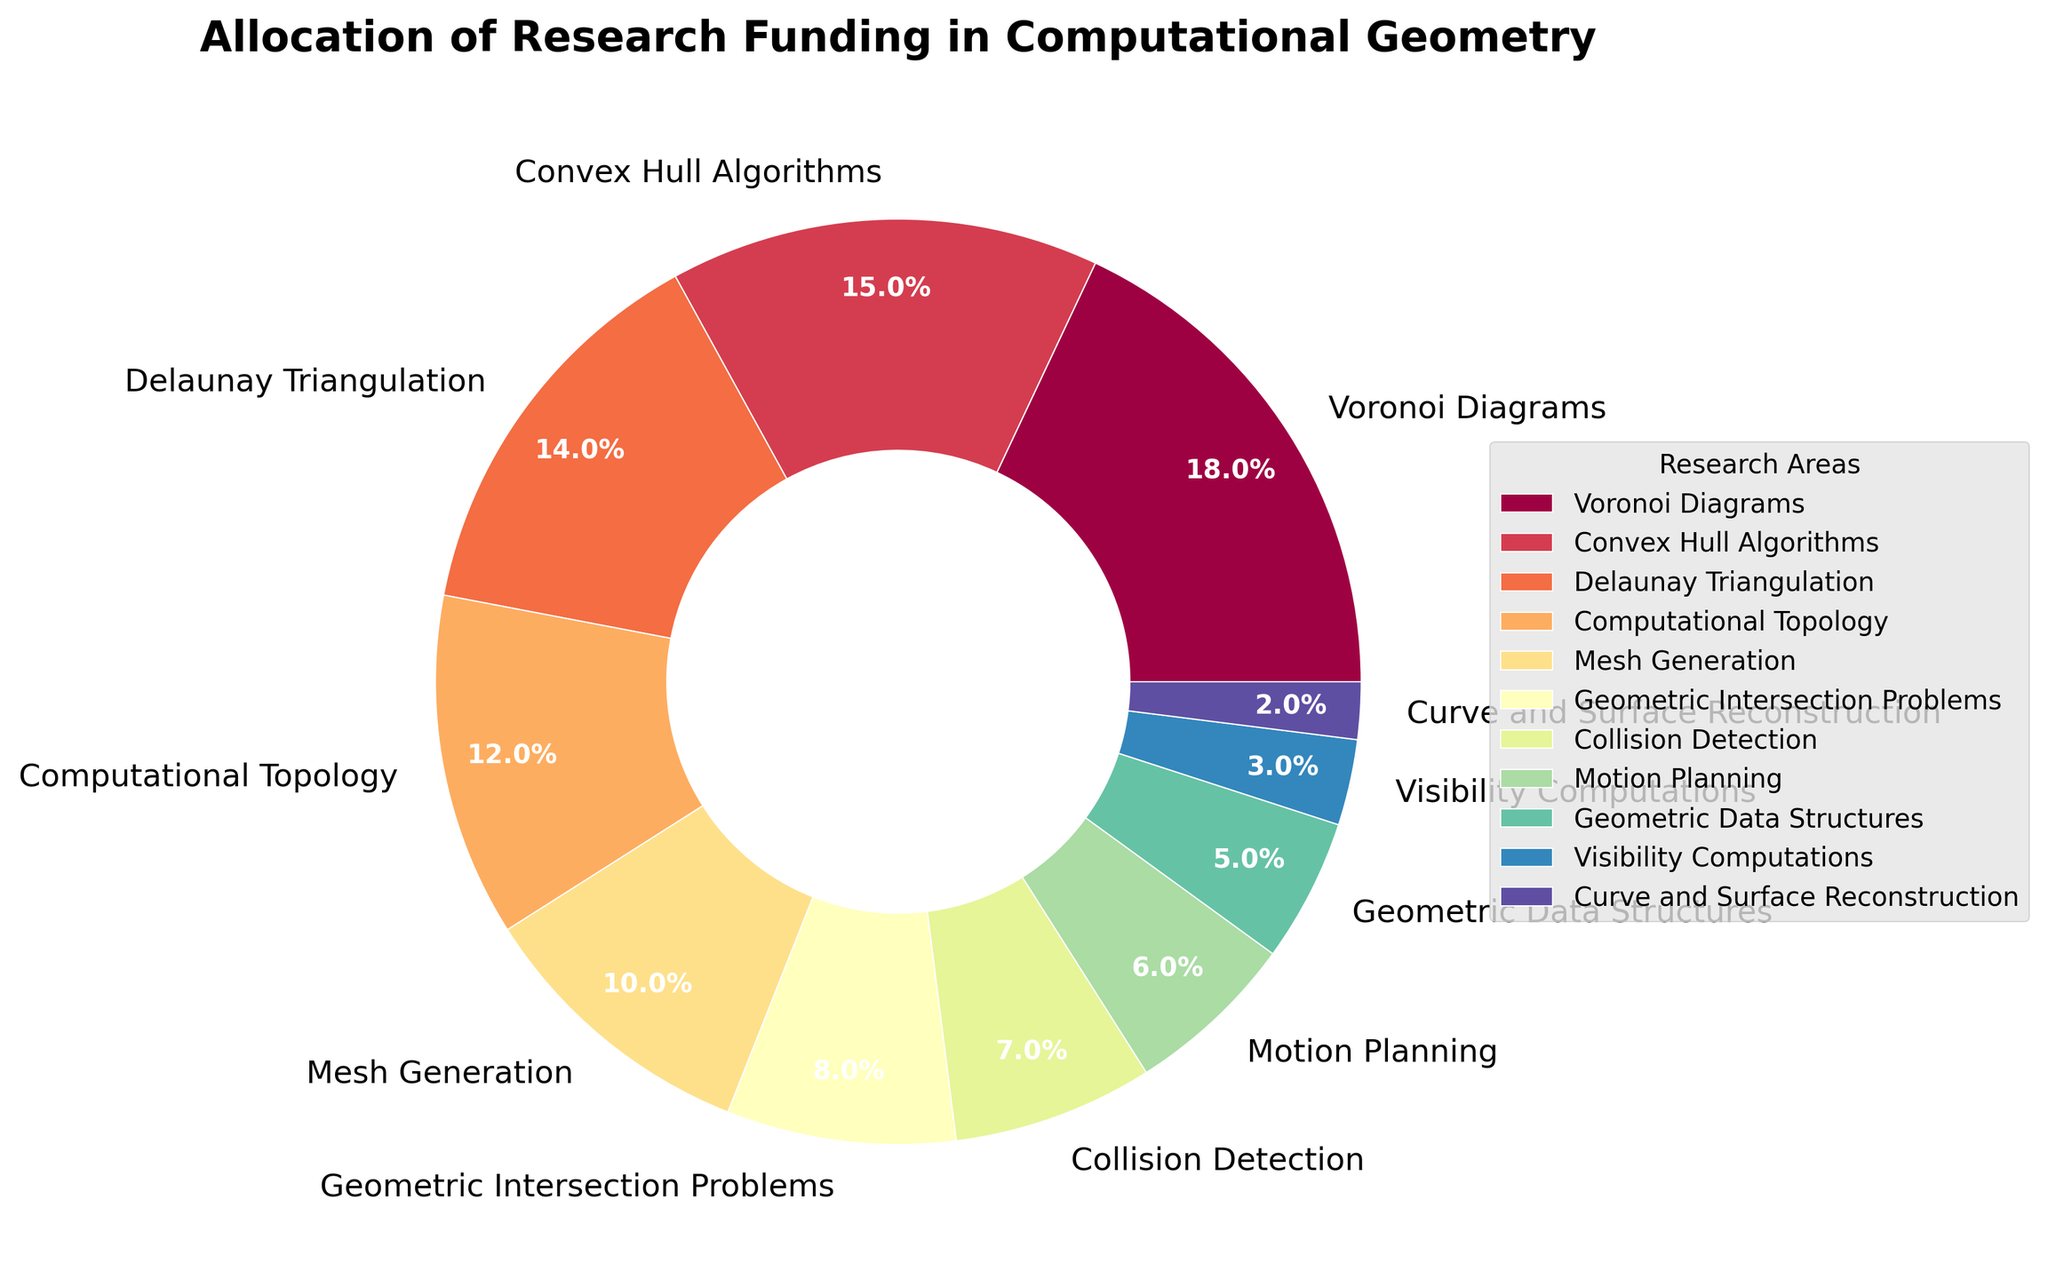Which area receives the highest percentage of funding? The area with the highest percentage of funding can be identified by looking at the largest segment in the pie chart. The label for this segment indicates it is "Voronoi Diagrams," with 18%.
Answer: Voronoi Diagrams What is the total percentage of funding allocated to Convex Hull Algorithms and Delaunay Triangulation combined? The funding percentages for Convex Hull Algorithms and Delaunay Triangulation are 15% and 14%, respectively. Adding these together gives 15% + 14% = 29%.
Answer: 29% Which areas receive equal funding, if any? By examining the pie chart, we need to look for segments that have the same percentage. It is visible that there are no two areas with the exact same percentage as each area has a unique value.
Answer: None Which area receives less funding, Motion Planning or Collision Detection? By comparing the funding percentages of Motion Planning and Collision Detection, we see that Motion Planning has 6%, while Collision Detection has 7%. Motion Planning receives less funding.
Answer: Motion Planning How much more funding does Mesh Generation receive compared to Visibility Computations? The funding percentages are 10% for Mesh Generation and 3% for Visibility Computations. The difference is calculated by subtracting 3% from 10%, resulting in 10% - 3% = 7%.
Answer: 7% List the three areas with the lowest funding. The pie chart shows that Curve and Surface Reconstruction, Visibility Computations, and Geometric Data Structures have the lowest funding, with 2%, 3%, and 5%, respectively.
Answer: Curve and Surface Reconstruction, Visibility Computations, Geometric Data Structures What is the combined funding percentage for areas focusing on geometric intersections and collision detection? The areas "Geometric Intersection Problems" and "Collision Detection" have funding percentages of 8% and 7%, respectively. Adding these together gives 8% + 7% = 15%.
Answer: 15% Which area receives more funding: Computational Topology or Motion Planning? By comparing the percentages, Computational Topology receives 12% of the funding while Motion Planning receives 6%. Therefore, Computational Topology receives more funding.
Answer: Computational Topology Which segment in the pie chart is visually the smallest, and what does it represent? The smallest segment can be identified visually as the thinnest slice in the pie chart. This segment has a label for "Curve and Surface Reconstruction" with 2%.
Answer: Curve and Surface Reconstruction 